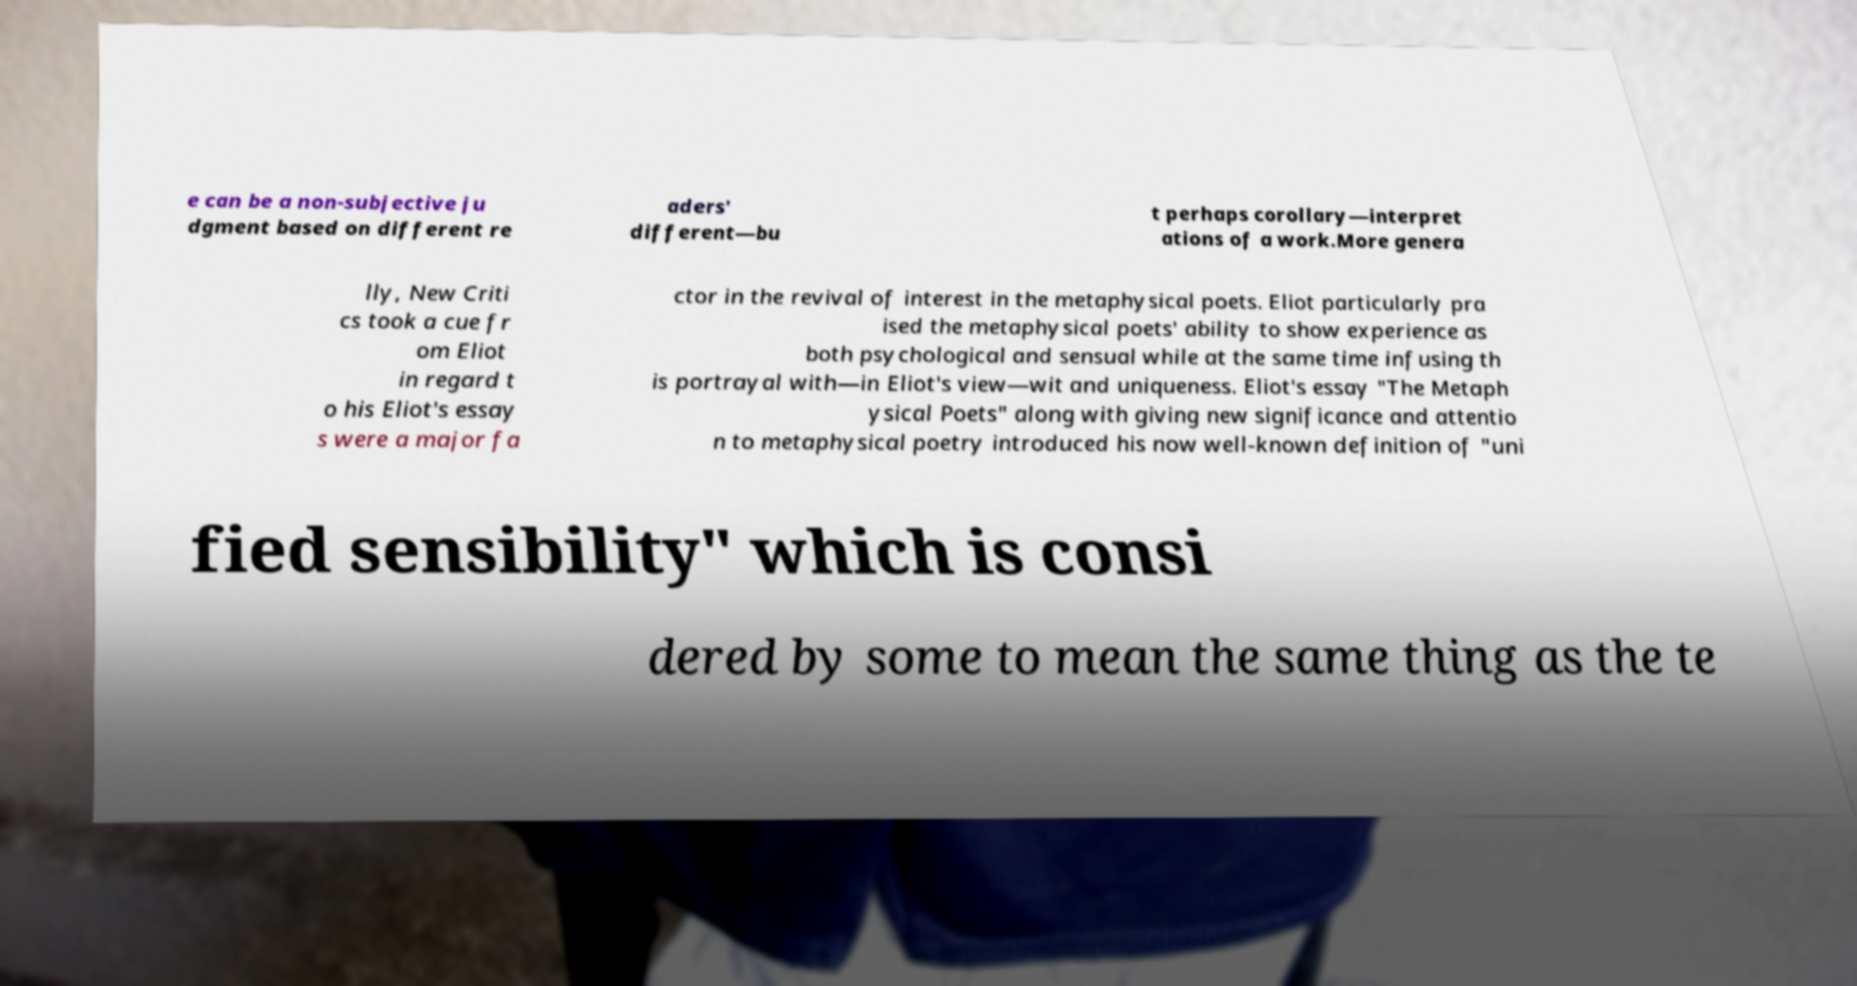Can you read and provide the text displayed in the image?This photo seems to have some interesting text. Can you extract and type it out for me? e can be a non-subjective ju dgment based on different re aders' different—bu t perhaps corollary—interpret ations of a work.More genera lly, New Criti cs took a cue fr om Eliot in regard t o his Eliot's essay s were a major fa ctor in the revival of interest in the metaphysical poets. Eliot particularly pra ised the metaphysical poets' ability to show experience as both psychological and sensual while at the same time infusing th is portrayal with—in Eliot's view—wit and uniqueness. Eliot's essay "The Metaph ysical Poets" along with giving new significance and attentio n to metaphysical poetry introduced his now well-known definition of "uni fied sensibility" which is consi dered by some to mean the same thing as the te 